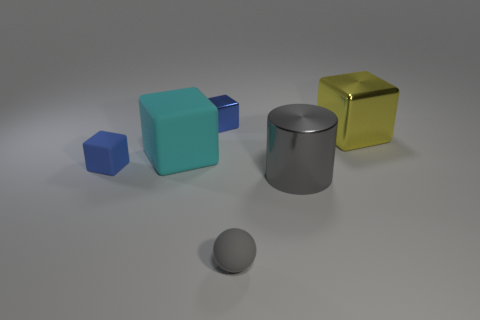What material is the other block that is the same color as the small matte block?
Keep it short and to the point. Metal. How many other objects are the same color as the big metal block?
Give a very brief answer. 0. Is the color of the big metal cube the same as the ball?
Make the answer very short. No. What is the size of the metallic object in front of the shiny block that is on the right side of the tiny gray matte thing?
Provide a short and direct response. Large. Does the tiny block to the right of the big cyan block have the same material as the small blue cube that is in front of the large yellow shiny cube?
Your answer should be compact. No. Is the color of the metal cube left of the gray sphere the same as the large metal cube?
Your answer should be compact. No. Are the small gray sphere and the tiny blue object that is behind the small blue matte cube made of the same material?
Keep it short and to the point. No. There is a tiny sphere; is it the same color as the large thing in front of the large matte thing?
Your answer should be very brief. Yes. What is the material of the cube right of the gray thing that is behind the ball?
Keep it short and to the point. Metal. What number of big cylinders have the same color as the sphere?
Make the answer very short. 1. 